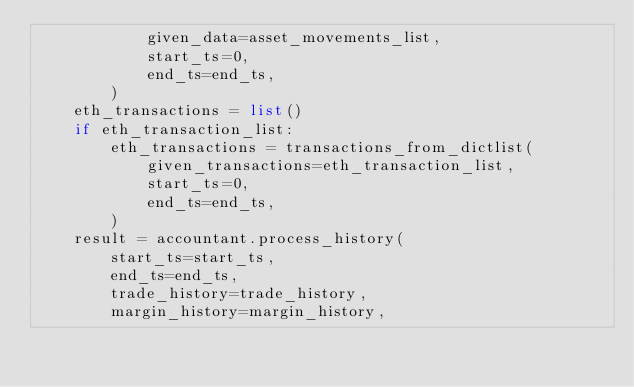<code> <loc_0><loc_0><loc_500><loc_500><_Python_>            given_data=asset_movements_list,
            start_ts=0,
            end_ts=end_ts,
        )
    eth_transactions = list()
    if eth_transaction_list:
        eth_transactions = transactions_from_dictlist(
            given_transactions=eth_transaction_list,
            start_ts=0,
            end_ts=end_ts,
        )
    result = accountant.process_history(
        start_ts=start_ts,
        end_ts=end_ts,
        trade_history=trade_history,
        margin_history=margin_history,</code> 